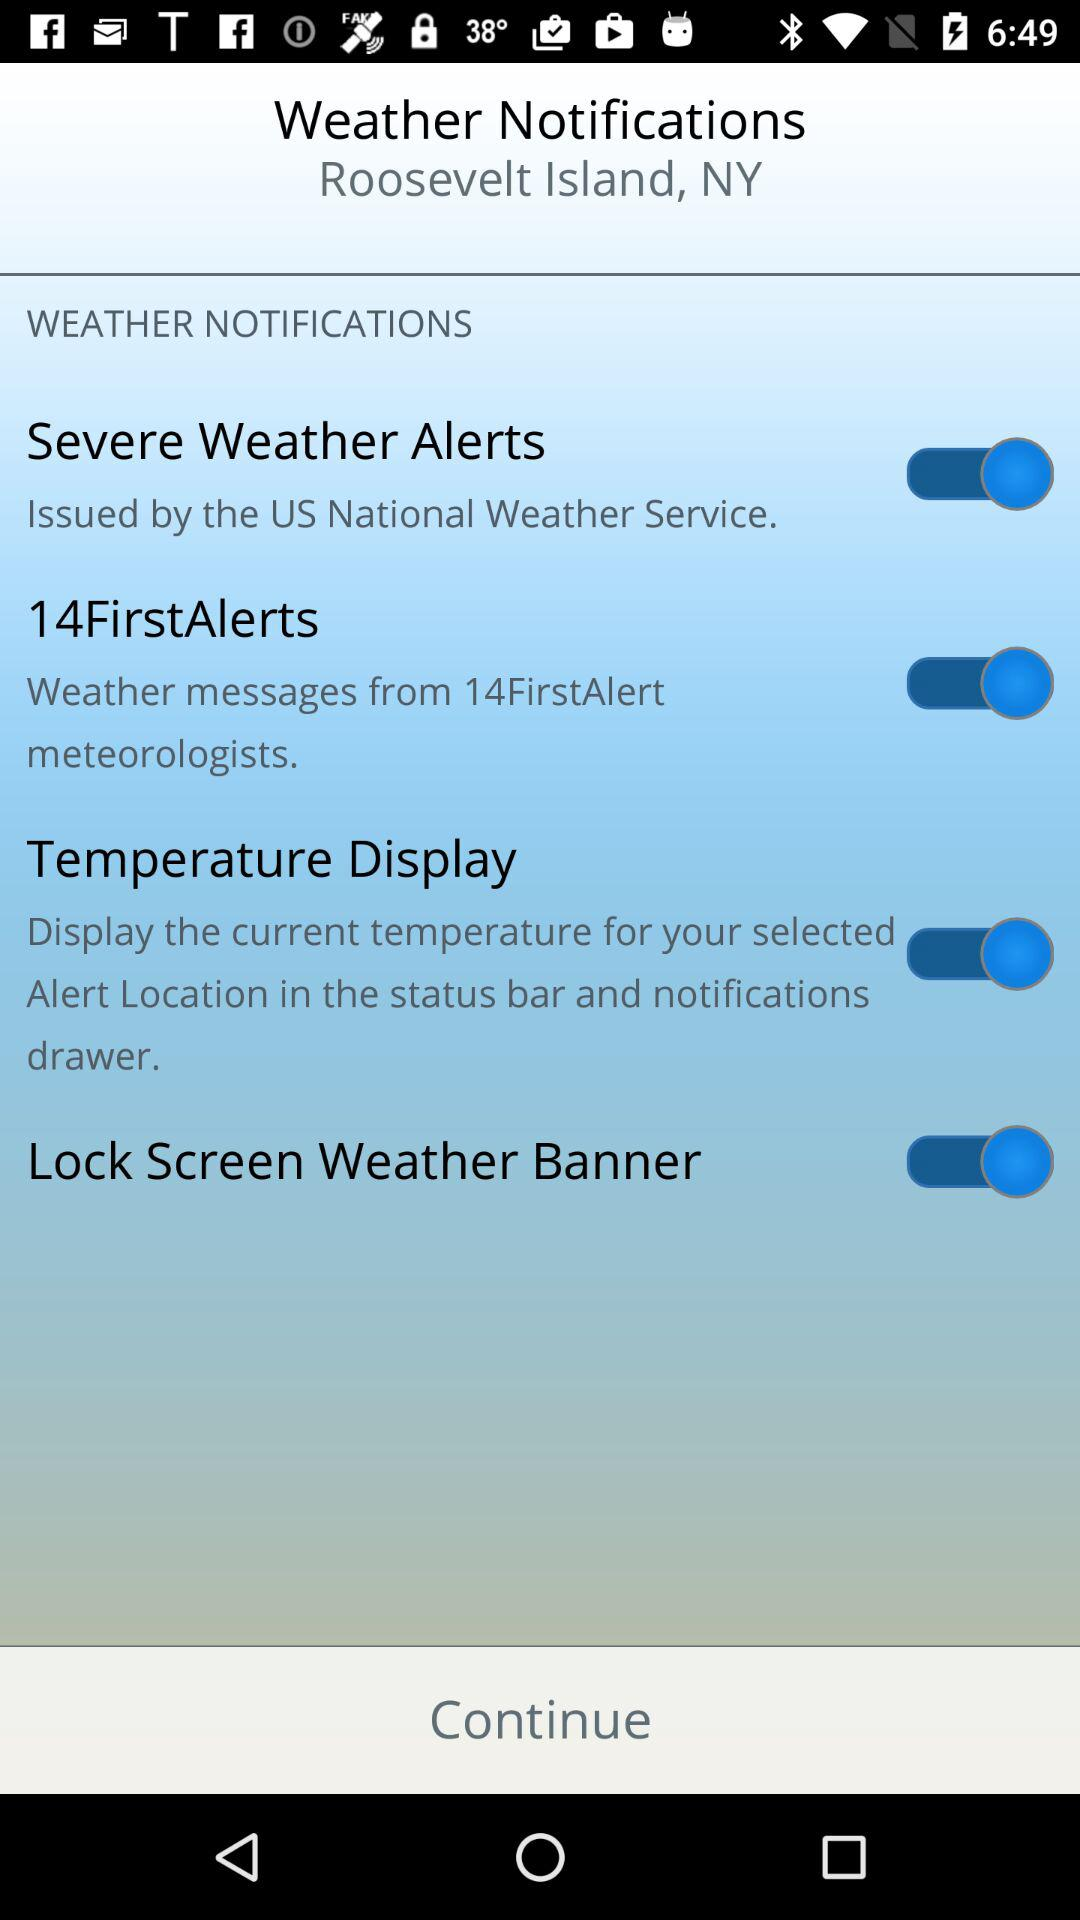What is the current status of the "Lock Screen Weather Banner"? The current status is "on". 